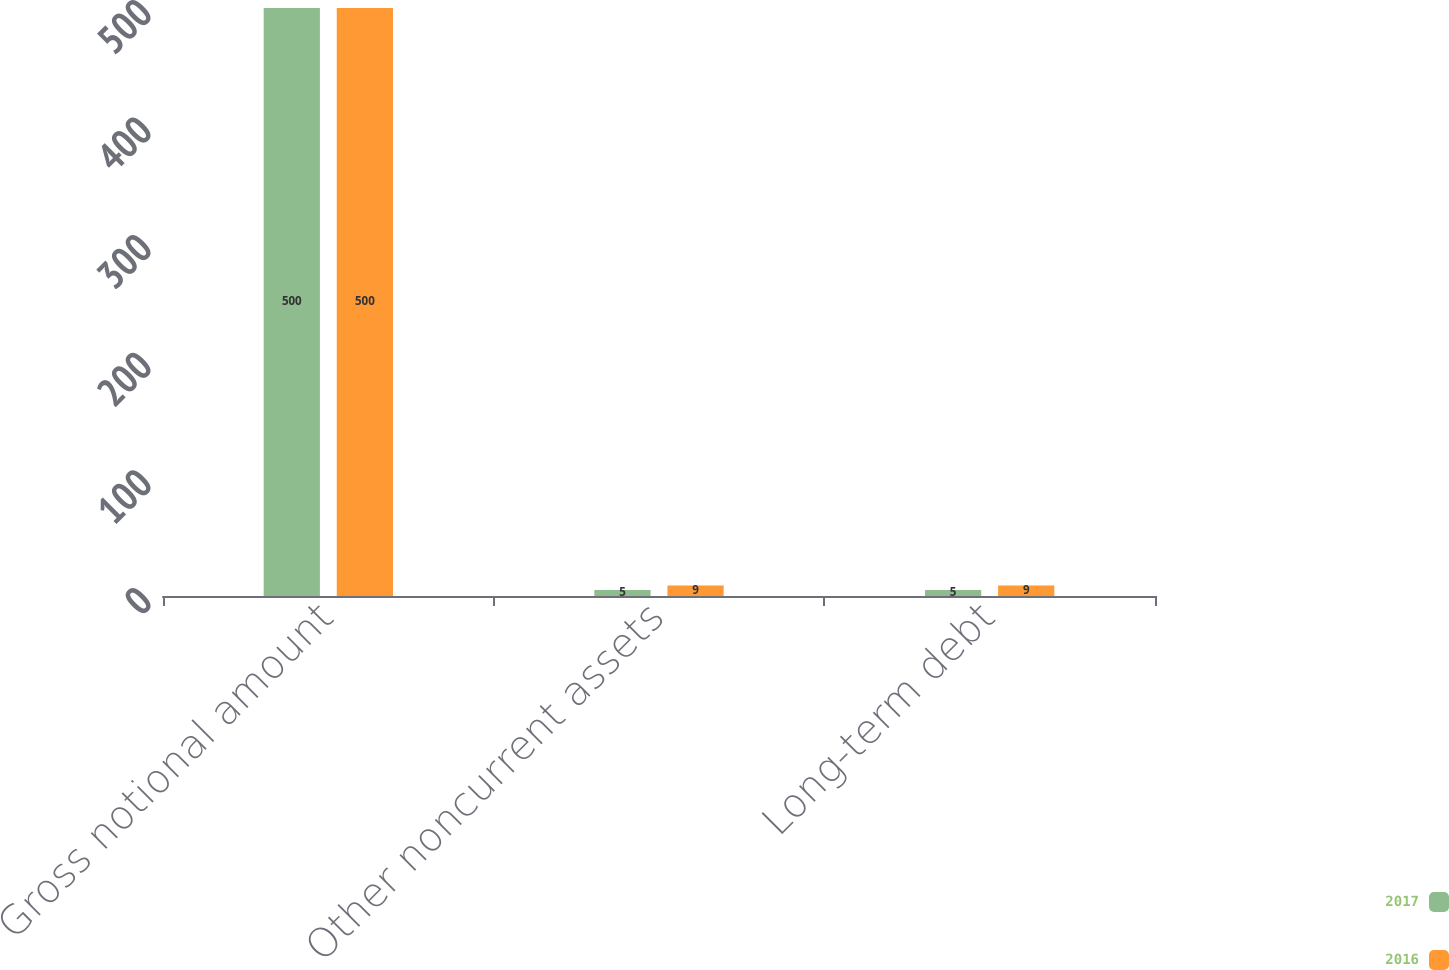Convert chart to OTSL. <chart><loc_0><loc_0><loc_500><loc_500><stacked_bar_chart><ecel><fcel>Gross notional amount<fcel>Other noncurrent assets<fcel>Long-term debt<nl><fcel>2017<fcel>500<fcel>5<fcel>5<nl><fcel>2016<fcel>500<fcel>9<fcel>9<nl></chart> 